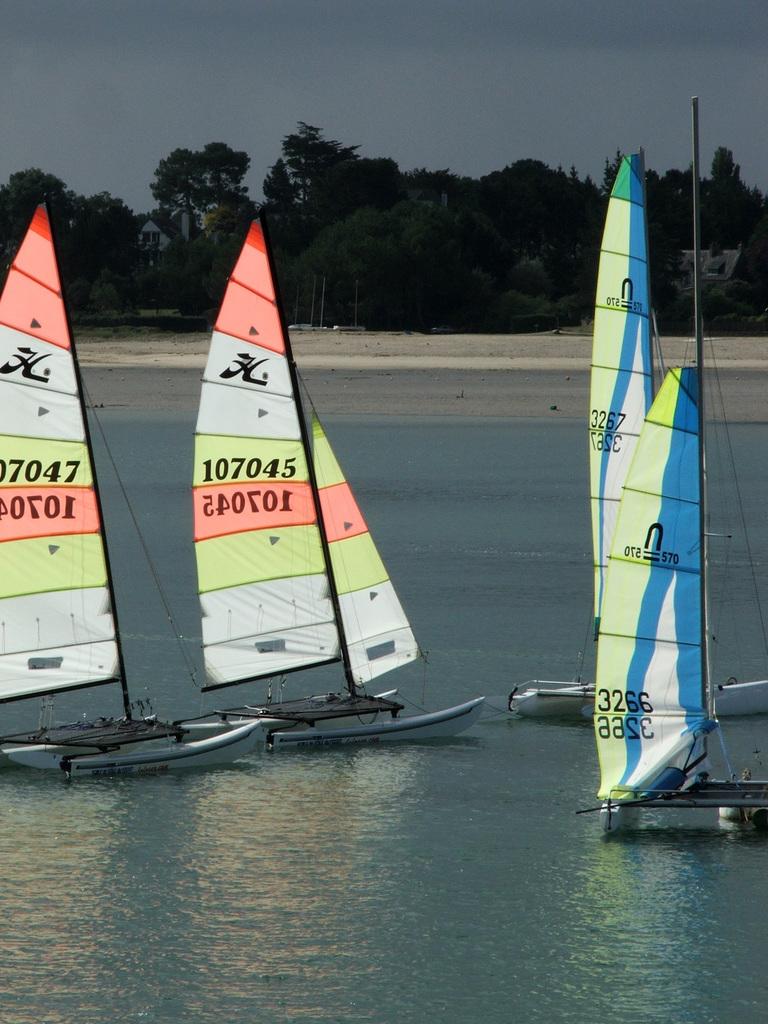What is written on the boat's sails?
Make the answer very short. 107045. What is the number on the boat sail in the middle?
Make the answer very short. 107045. 